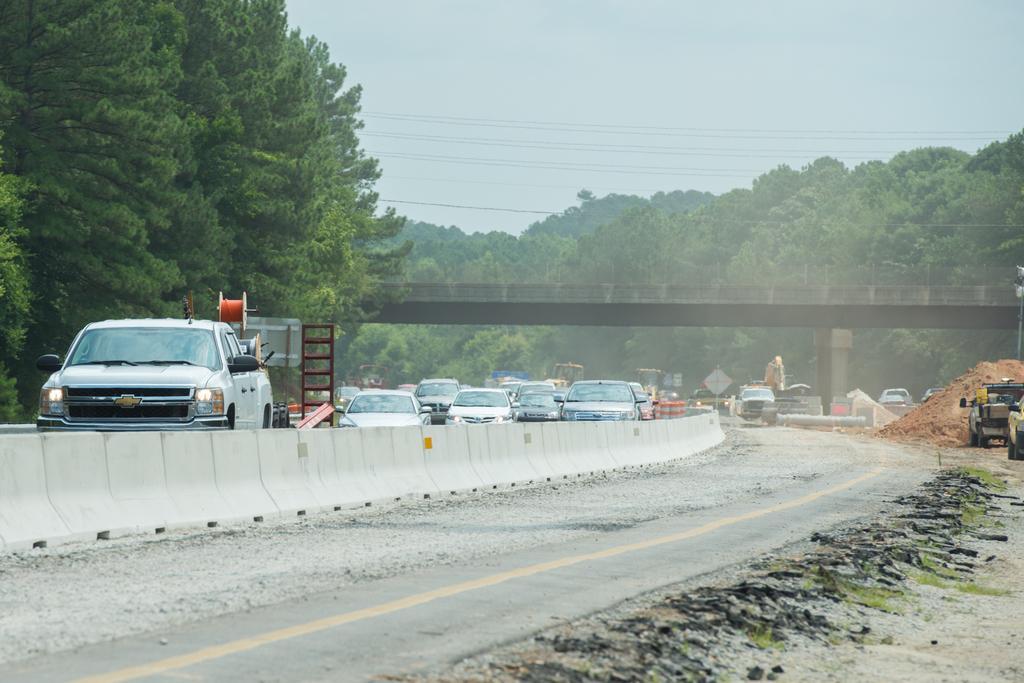How would you summarize this image in a sentence or two? In this image in the center there are vehicles moving on the road. In the background there are trees, there is a bridge and on the right side there is a sand on the ground, and the sky is cloudy. 